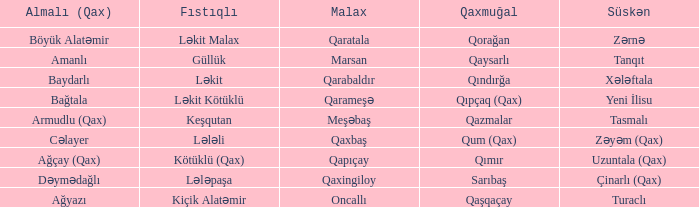What is the Almali village with the Malax village qaxingiloy? Dəymədağlı. Write the full table. {'header': ['Almalı (Qax)', 'Fıstıqlı', 'Malax', 'Qaxmuğal', 'Süskən'], 'rows': [['Böyük Alatəmir', 'Ləkit Malax', 'Qaratala', 'Qorağan', 'Zərnə'], ['Amanlı', 'Güllük', 'Marsan', 'Qaysarlı', 'Tanqıt'], ['Baydarlı', 'Ləkit', 'Qarabaldır', 'Qındırğa', 'Xələftala'], ['Bağtala', 'Ləkit Kötüklü', 'Qarameşə', 'Qıpçaq (Qax)', 'Yeni İlisu'], ['Armudlu (Qax)', 'Keşqutan', 'Meşəbaş', 'Qazmalar', 'Tasmalı'], ['Cəlayer', 'Lələli', 'Qaxbaş', 'Qum (Qax)', 'Zəyəm (Qax)'], ['Ağçay (Qax)', 'Kötüklü (Qax)', 'Qapıçay', 'Qımır', 'Uzuntala (Qax)'], ['Dəymədağlı', 'Lələpaşa', 'Qaxingiloy', 'Sarıbaş', 'Çinarlı (Qax)'], ['Ağyazı', 'Kiçik Alatəmir', 'Oncallı', 'Qaşqaçay', 'Turaclı']]} 